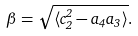<formula> <loc_0><loc_0><loc_500><loc_500>\beta = \sqrt { \langle c _ { 2 } ^ { 2 } - a _ { 4 } a _ { 3 } \rangle } .</formula> 